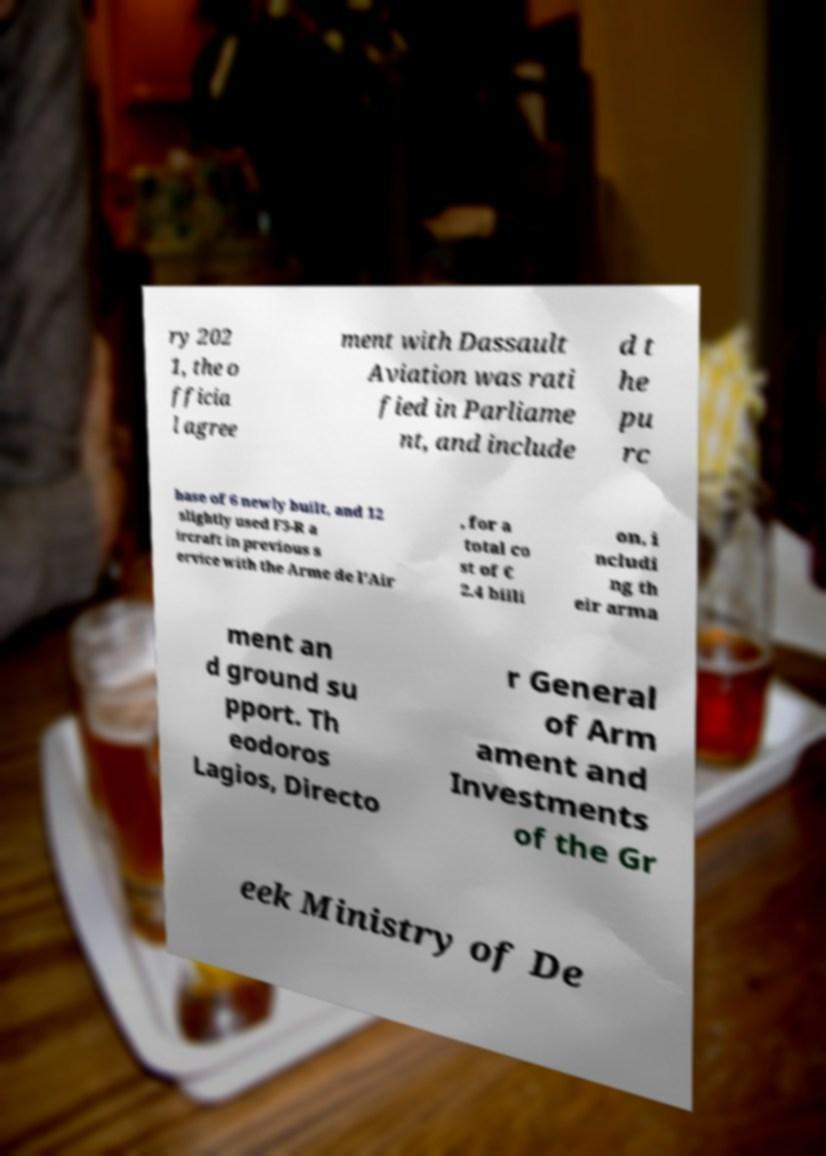Can you read and provide the text displayed in the image?This photo seems to have some interesting text. Can you extract and type it out for me? ry 202 1, the o fficia l agree ment with Dassault Aviation was rati fied in Parliame nt, and include d t he pu rc hase of 6 newly built, and 12 slightly used F3-R a ircraft in previous s ervice with the Arme de l'Air , for a total co st of € 2.4 billi on, i ncludi ng th eir arma ment an d ground su pport. Th eodoros Lagios, Directo r General of Arm ament and Investments of the Gr eek Ministry of De 